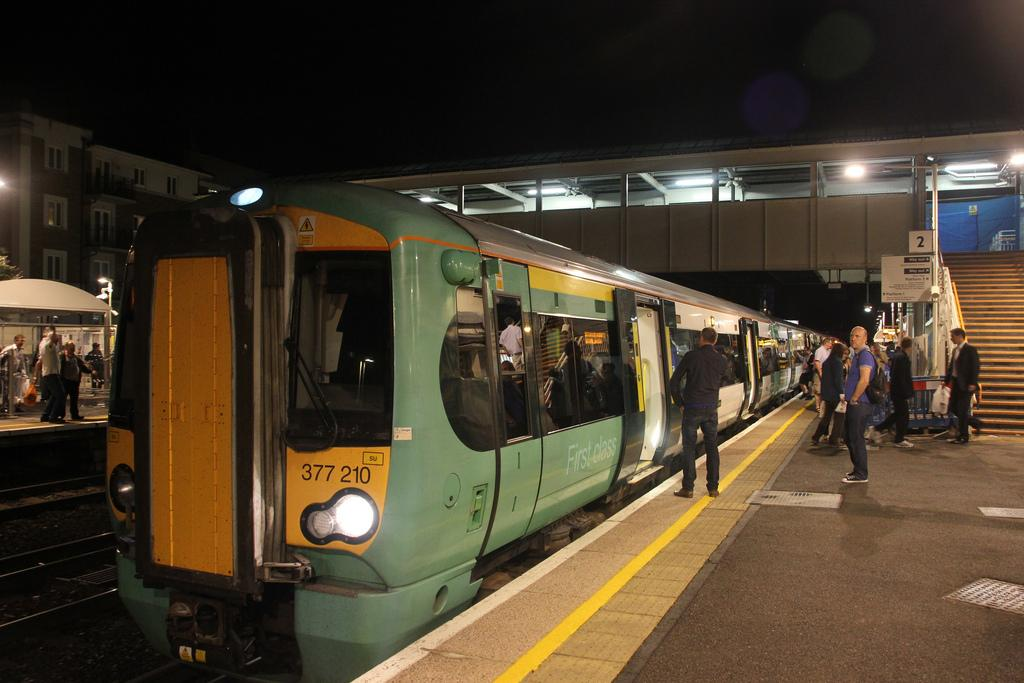Identify any instances of people interacting with the train directly. There is a man in a blue shirt standing on the train platform and another man standing by the open door of the train. Determine if there are any environmental elements that could help identify the time of day. The black night sky in the image suggests that this scene is taking place during nighttime. Assess the image for any unusual or unexpected elements. One unusual element within the image is the presence of a square on the ground, which could be an art installation or an unrelated object. In a few words, communicate the primary narrative happening in this scene. People waiting on a train platform while a green and yellow train is stopped with its doors open. Explain the purpose of the white sign with the number 2 on it. The white sign with the number 2 is likely used to indicate the platform number at the train station. Examine the image for any structural components, such as walls and stairways. In the image, there are walls on the sides of a building, a stairway painted with a yellow stripe, and a walkway over the subway tracks. Based on the context of the image, what type of transportation is being depicted? The image depicts a train station, showcasing a train stopped next to a platform with people waiting. List any articles of clothing worn by the people in the image. Some articles of clothing include: blue shirt, backpack, black business suit, black leather jacket, and white shirt. Examine the image for any safety features on the train platform. A yellow line is present on the train platform, likely to ensure the safety of passengers by providing guidance on where to stand. Identify any color patterns you can observe in the image. Notable color patterns include yellow on various surfaces (doors, line on platform, stairway stripe) and the train being green and yellow. Can you see any man on the train platform wearing a jacket? Yes, there is a man wearing a black leather jacket. Find the color of the wall which is on the side of the building. The wall is blue. Is there a yellow line on the train platform? If so, describe where it is located. Yes, the yellow line is on the train platform near the edge. Read the number displayed on the white sign. 2 Can you see a white sky in the image at position X:5 Y:4 with Width:1016 Height:1016? The sky in the image is black, not white. What color is the train that stopped next to the platform? green and yellow Create a short story related to the image. On a quiet night, Jack arrives at the train station just as the green and yellow train pulls in. The train headlights illuminate the dark platform, and Jack notices a man in a blue shirt awaiting the train. Jack watches the open yellow door, the hustle of passengers, and wonders where their journeys will take them. Is the train door closed at the position X:611 Y:286 with Width:70 Height:70? The door at the specified location is open, not closed. Identify the walkway in the image, and describe its appearance. The walkway is over the subway tracks and is covered with a white canopy. Describe the man who is standing near the train platform. A man in a blue shirt, bald, and carrying a black backpack stands on the train platform. Is there a blue line on the train platform located at X:472 Y:225 with Width:419 Height:419? The line on the train platform is yellow, not blue. State the event that occurred on the train platform. People are waiting at the train station while the green and yellow train has stopped next to the platform with open doors. Imagine you are a passerby in the image. Describe what you see in the underground train station. As I walk by, I see a green and yellow train with open doors and black windows, stopped next to a platform with a yellow line. A man wearing a blue shirt is waiting at the platform, carrying a black backpack. Identify the shelter provided for passengers near the walkway. A white canopy Can you find the man wearing a red shirt at X:807 Y:282 with Width:141 Height:141? The man at the specified location is wearing a blue shirt, not a red one. What color is the stairway stripe? yellow How many train doors are open in the image? Two doors are open. From the below options, choose the accurate description of the man with a backpack:  b. Man in a red shirt with a backpack What is above the staircase in the scene? A blue wall Does the man with the green backpack stand at X:868 Y:362 with Width:21 Height:21? The backpack at the specified location is black, not green. Which of the following is true about the train headlights in the image?  b. The left headlight is unlit while the right one is lit Describe the attire of the man standing near the stairs. The man is wearing a black business suit. Is the headlight that is off located at X:287 Y:476 with Width:98 Height:98? The given coordinates and size refer to the lit headlight, not the unlit one. 